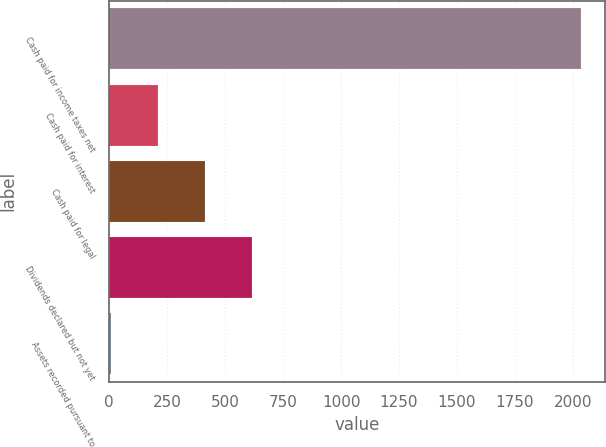<chart> <loc_0><loc_0><loc_500><loc_500><bar_chart><fcel>Cash paid for income taxes net<fcel>Cash paid for interest<fcel>Cash paid for legal<fcel>Dividends declared but not yet<fcel>Assets recorded pursuant to<nl><fcel>2036<fcel>210.8<fcel>413.6<fcel>616.4<fcel>8<nl></chart> 